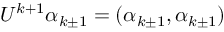<formula> <loc_0><loc_0><loc_500><loc_500>U ^ { k + 1 } \alpha _ { k \pm 1 } = ( \alpha _ { k \pm 1 } , \alpha _ { k \pm 1 } )</formula> 